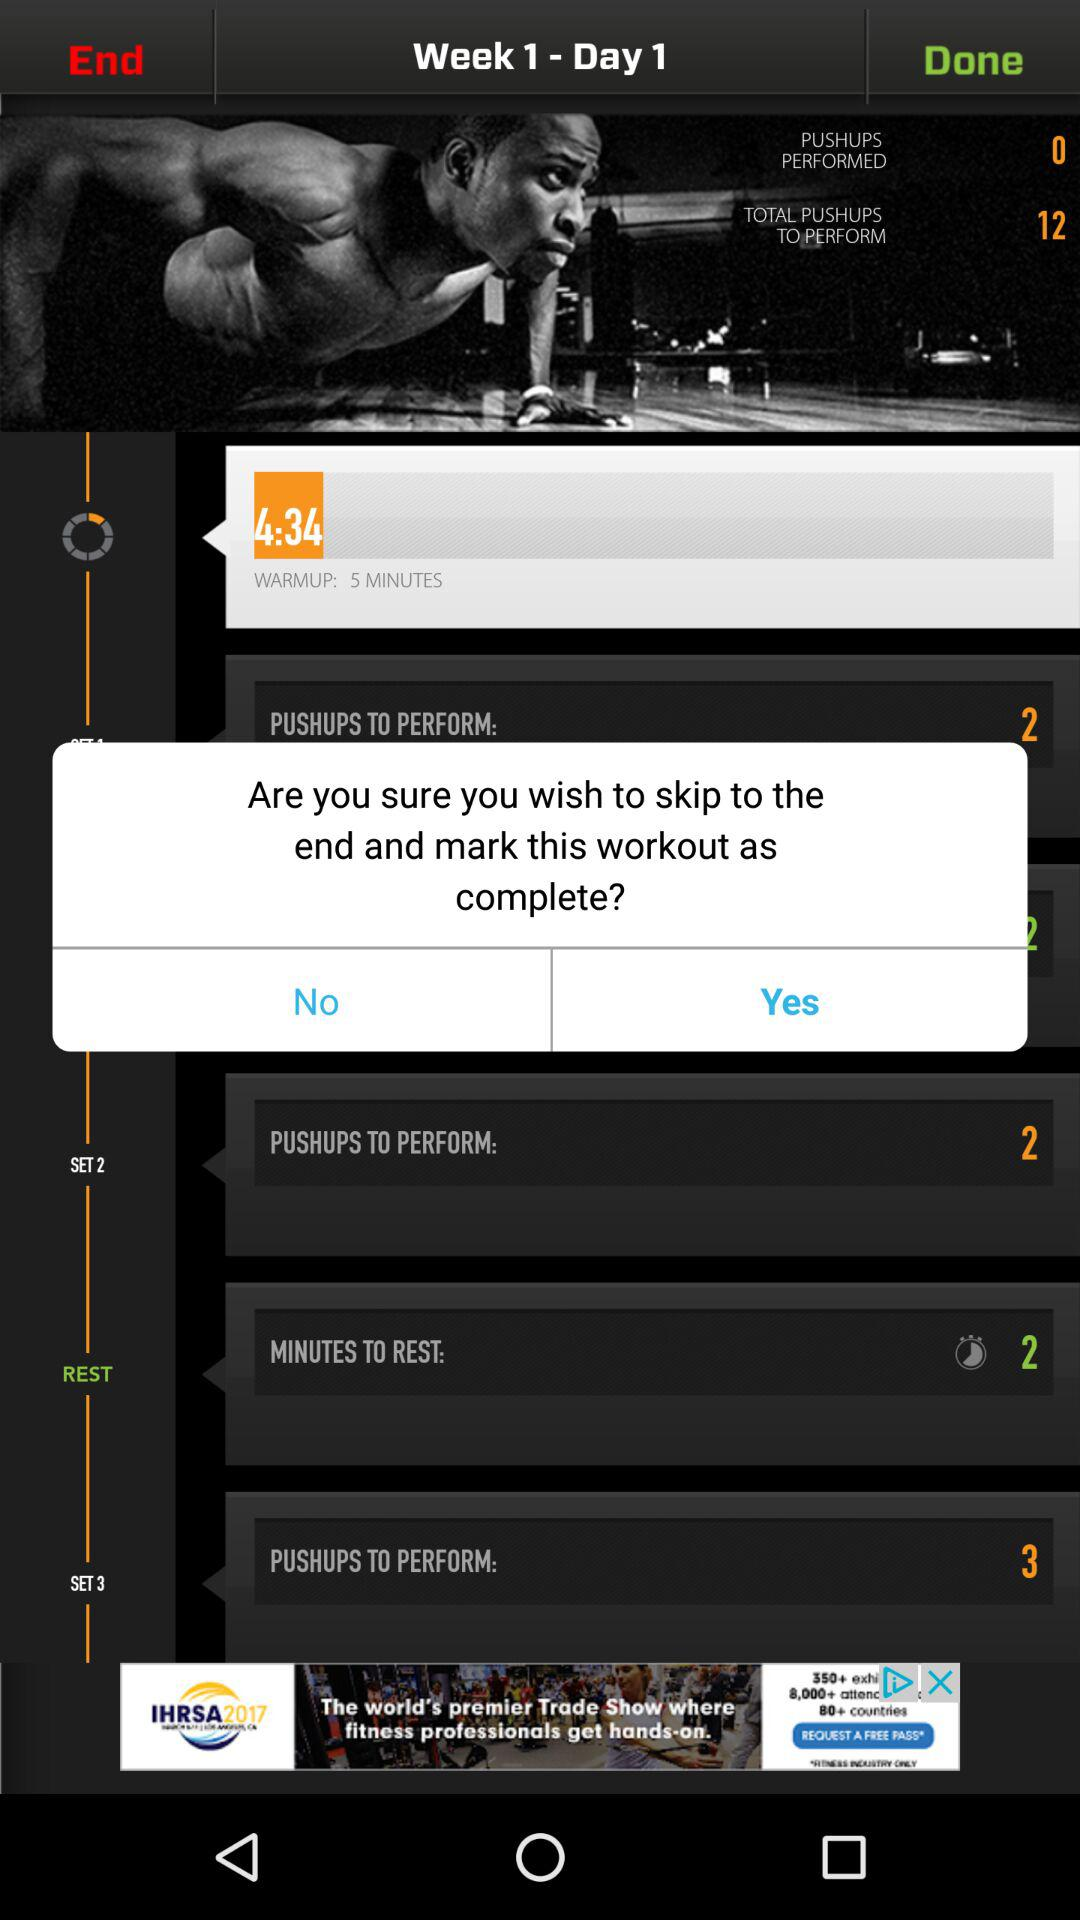What are the week number and day number? The week number is 1 and day number is 1. 